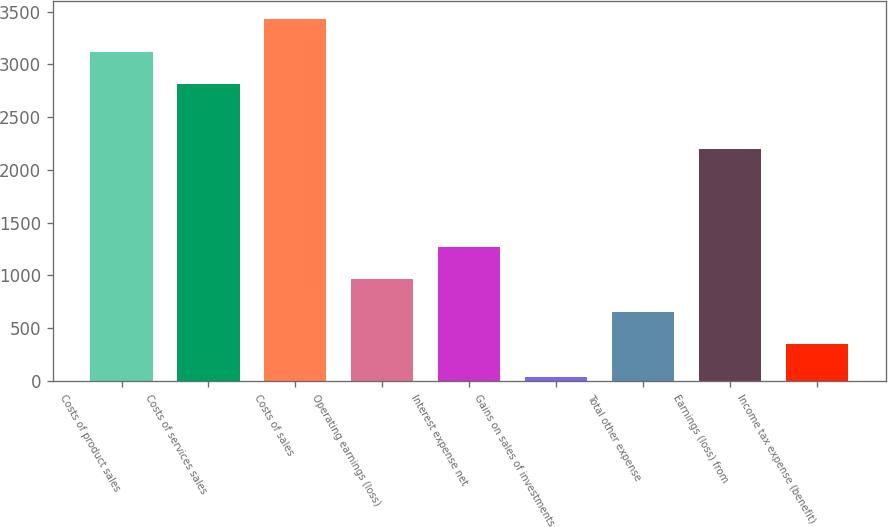Convert chart to OTSL. <chart><loc_0><loc_0><loc_500><loc_500><bar_chart><fcel>Costs of product sales<fcel>Costs of services sales<fcel>Costs of sales<fcel>Operating earnings (loss)<fcel>Interest expense net<fcel>Gains on sales of investments<fcel>Total other expense<fcel>Earnings (loss) from<fcel>Income tax expense (benefit)<nl><fcel>3118<fcel>2809.9<fcel>3426.1<fcel>961.3<fcel>1269.4<fcel>37<fcel>653.2<fcel>2193.7<fcel>345.1<nl></chart> 